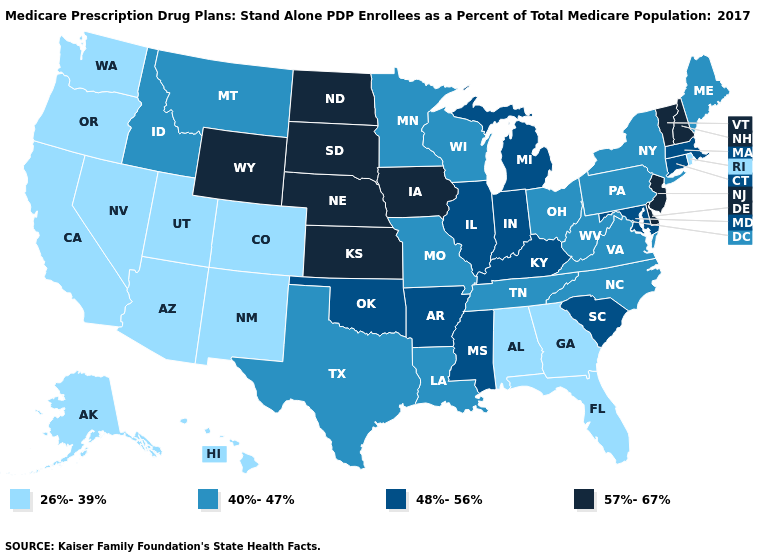Among the states that border New Jersey , does New York have the highest value?
Write a very short answer. No. Name the states that have a value in the range 40%-47%?
Quick response, please. Idaho, Louisiana, Maine, Minnesota, Missouri, Montana, North Carolina, New York, Ohio, Pennsylvania, Tennessee, Texas, Virginia, Wisconsin, West Virginia. Does Massachusetts have the lowest value in the USA?
Answer briefly. No. Does Texas have a lower value than North Dakota?
Keep it brief. Yes. Name the states that have a value in the range 26%-39%?
Short answer required. Alaska, Alabama, Arizona, California, Colorado, Florida, Georgia, Hawaii, New Mexico, Nevada, Oregon, Rhode Island, Utah, Washington. What is the highest value in states that border Kansas?
Concise answer only. 57%-67%. What is the highest value in states that border Washington?
Write a very short answer. 40%-47%. What is the lowest value in the USA?
Answer briefly. 26%-39%. What is the value of Delaware?
Be succinct. 57%-67%. Name the states that have a value in the range 48%-56%?
Short answer required. Arkansas, Connecticut, Illinois, Indiana, Kentucky, Massachusetts, Maryland, Michigan, Mississippi, Oklahoma, South Carolina. Does Kentucky have the same value as Montana?
Short answer required. No. Which states hav the highest value in the South?
Quick response, please. Delaware. What is the value of Massachusetts?
Answer briefly. 48%-56%. What is the value of Maine?
Write a very short answer. 40%-47%. How many symbols are there in the legend?
Answer briefly. 4. 